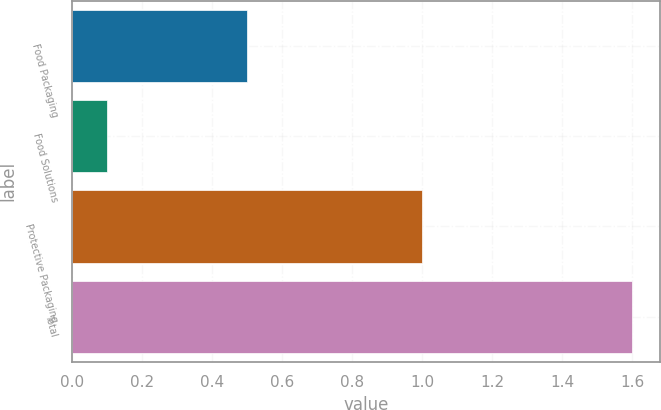<chart> <loc_0><loc_0><loc_500><loc_500><bar_chart><fcel>Food Packaging<fcel>Food Solutions<fcel>Protective Packaging<fcel>Total<nl><fcel>0.5<fcel>0.1<fcel>1<fcel>1.6<nl></chart> 